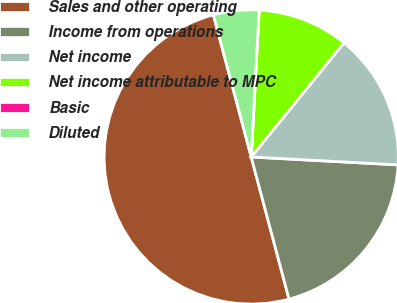Convert chart to OTSL. <chart><loc_0><loc_0><loc_500><loc_500><pie_chart><fcel>Sales and other operating<fcel>Income from operations<fcel>Net income<fcel>Net income attributable to MPC<fcel>Basic<fcel>Diluted<nl><fcel>50.0%<fcel>20.0%<fcel>15.0%<fcel>10.0%<fcel>0.0%<fcel>5.0%<nl></chart> 